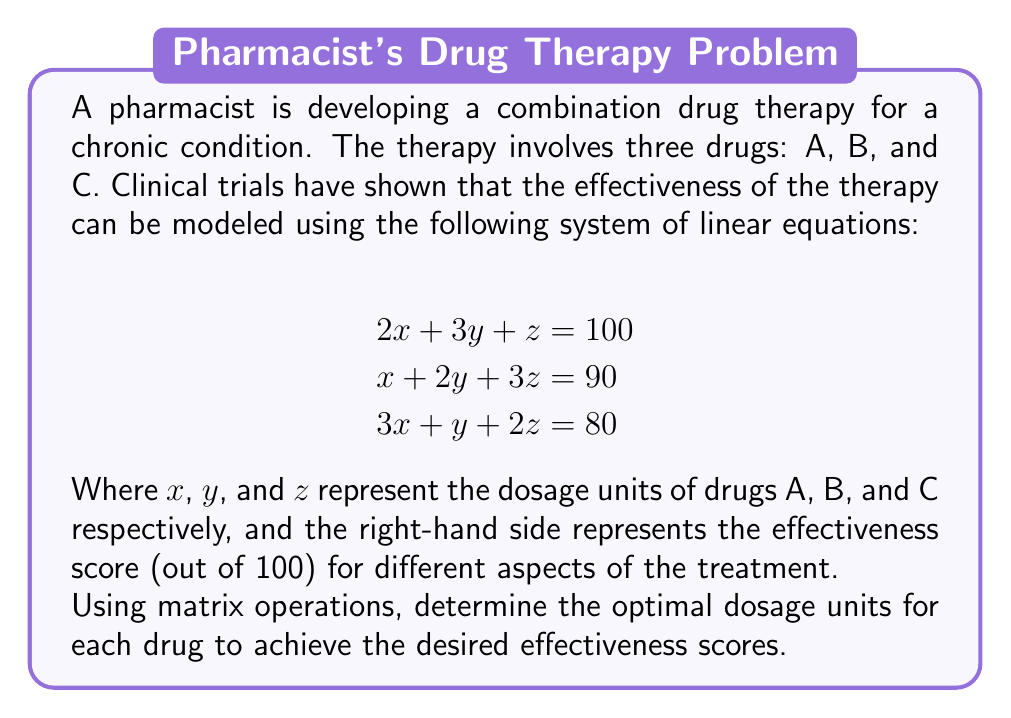Solve this math problem. To solve this problem, we'll use matrix operations, specifically Gaussian elimination or matrix inversion. Let's follow these steps:

1) First, we'll set up the augmented matrix:

$$\begin{bmatrix}
2 & 3 & 1 & | & 100 \\
1 & 2 & 3 & | & 90 \\
3 & 1 & 2 & | & 80
\end{bmatrix}$$

2) Now, we'll perform row operations to get the matrix in row echelon form:

   a) Multiply R1 by -1/2 and add to R2:
   $$\begin{bmatrix}
   2 & 3 & 1 & | & 100 \\
   0 & 1/2 & 5/2 & | & 40 \\
   3 & 1 & 2 & | & 80
   \end{bmatrix}$$

   b) Multiply R1 by -3/2 and add to R3:
   $$\begin{bmatrix}
   2 & 3 & 1 & | & 100 \\
   0 & 1/2 & 5/2 & | & 40 \\
   0 & -7/2 & 1/2 & | & -70
   \end{bmatrix}$$

3) Continue to reduce:

   c) Multiply R2 by 2:
   $$\begin{bmatrix}
   2 & 3 & 1 & | & 100 \\
   0 & 1 & 5 & | & 80 \\
   0 & -7/2 & 1/2 & | & -70
   \end{bmatrix}$$

   d) Multiply R2 by 7/2 and add to R3:
   $$\begin{bmatrix}
   2 & 3 & 1 & | & 100 \\
   0 & 1 & 5 & | & 80 \\
   0 & 0 & 18 & | & 210
   \end{bmatrix}$$

4) Now we have the matrix in row echelon form. We can solve for z, y, and x in reverse order:

   z = 210/18 = 35/3
   y = 80 - 5(35/3) = 80 - 175/3 = 65/3
   x = (100 - 3(65/3) - 35/3)/2 = (300 - 65 - 35)/6 = 200/6 = 100/3

Therefore, the optimal dosage units are:
x = 100/3 (Drug A)
y = 65/3 (Drug B)
z = 35/3 (Drug C)
Answer: The optimal dosage units are:
Drug A: $\frac{100}{3}$ units
Drug B: $\frac{65}{3}$ units
Drug C: $\frac{35}{3}$ units 